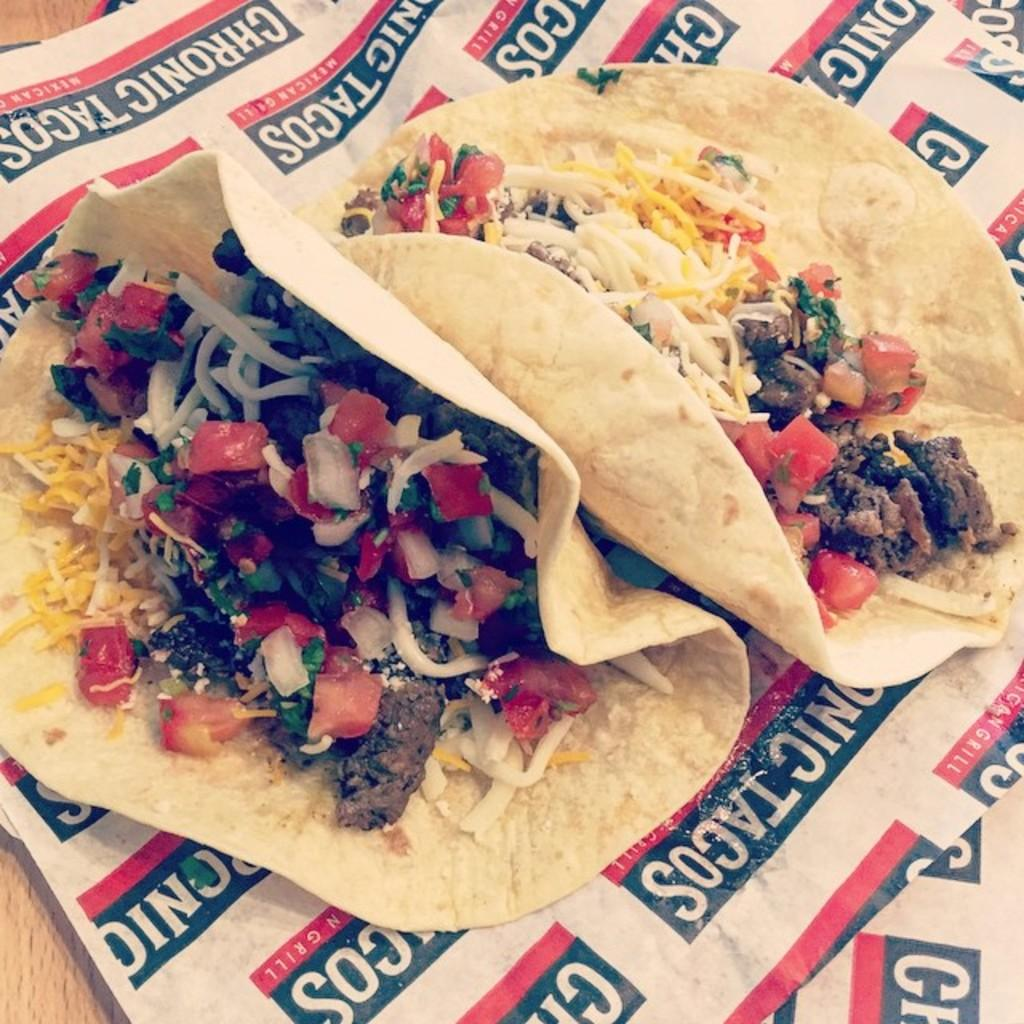What type of food is visible in the image? There is a food item made of vegetables in the image. What is located at the bottom of the image? There is a paper at the bottom of the image. What can be found on the paper? There is text written on the paper. How many dimes can be seen on the food item in the image? There are no dimes present in the image. Is there a toad sitting on top of the food item in the image? There is no toad present in the image. 